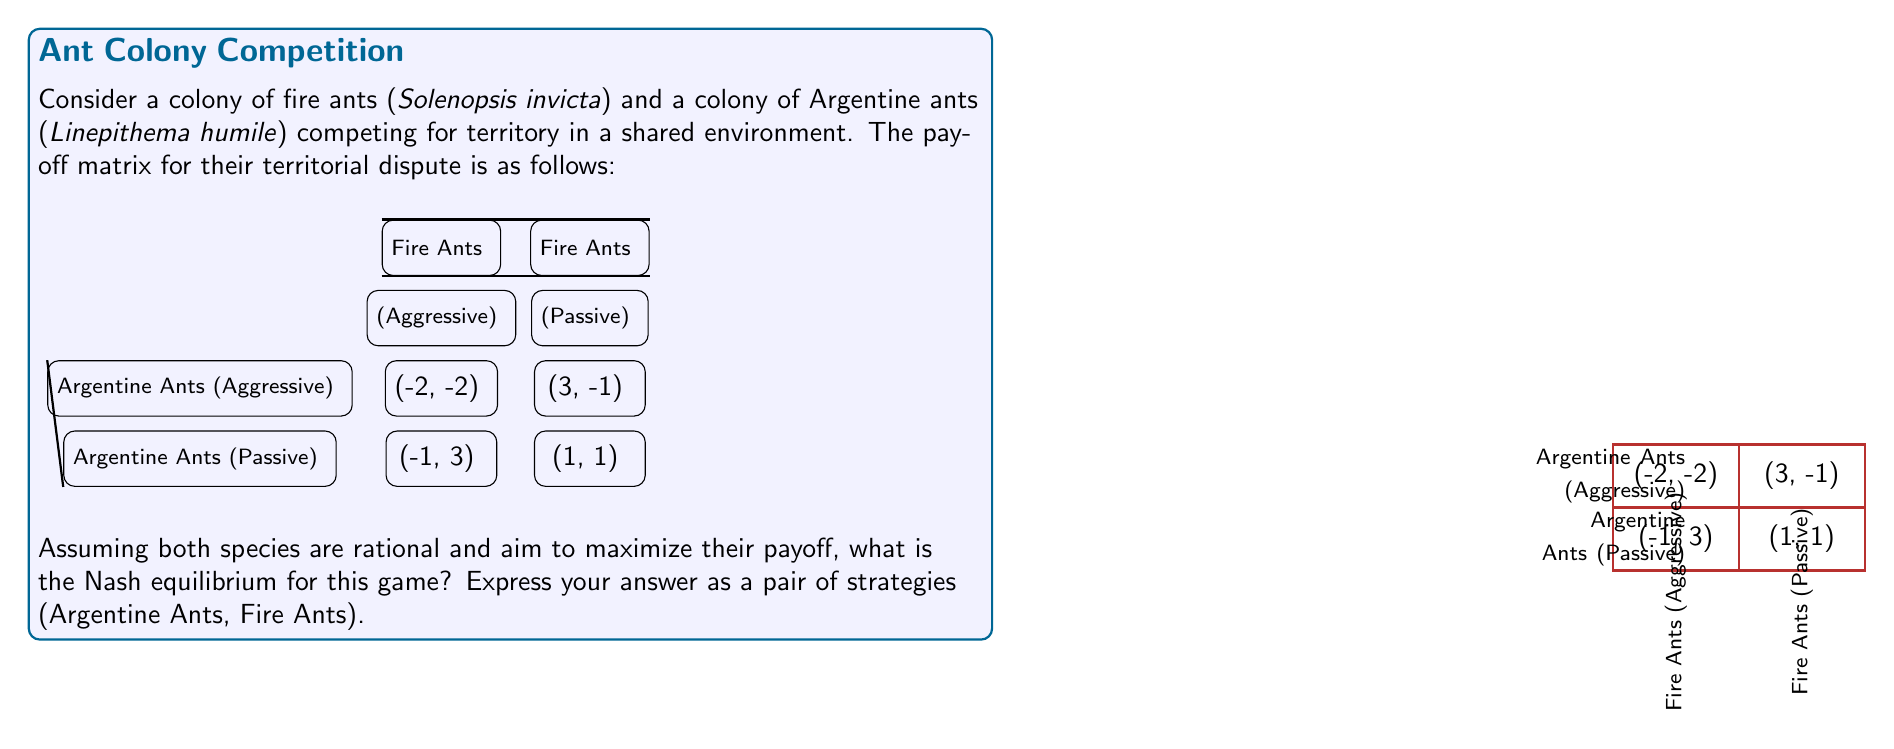Teach me how to tackle this problem. To find the Nash equilibrium, we need to analyze each species' best response to the other's strategy:

1. For Argentine Ants:
   - If Fire Ants play Aggressive: 
     Argentine Ants prefer Passive (-1 > -2)
   - If Fire Ants play Passive: 
     Argentine Ants prefer Aggressive (3 > 1)

2. For Fire Ants:
   - If Argentine Ants play Aggressive: 
     Fire Ants prefer Passive (-1 > -2)
   - If Argentine Ants play Passive: 
     Fire Ants prefer Aggressive (3 > 1)

3. We can see that there's no pure strategy Nash equilibrium, as no pair of strategies is a best response to each other.

4. For mixed strategy equilibrium, let:
   $p$ = probability of Argentine Ants playing Aggressive
   $q$ = probability of Fire Ants playing Aggressive

5. For Argentine Ants to be indifferent:
   $$-2q + 3(1-q) = -1q + 1(1-q)$$
   $$-2q + 3 - 3q = -q + 1$$
   $$-5q + 3 = -q + 1$$
   $$-4q = -2$$
   $$q = \frac{1}{2}$$

6. For Fire Ants to be indifferent:
   $$-2p + 3(1-p) = -1p + 1(1-p)$$
   $$-2p + 3 - 3p = -p + 1$$
   $$-5p + 3 = -p + 1$$
   $$-4p = -2$$
   $$p = \frac{1}{2}$$

7. Therefore, the mixed strategy Nash equilibrium is where both species play Aggressive with probability $\frac{1}{2}$ and Passive with probability $\frac{1}{2}$.
Answer: (50% Aggressive / 50% Passive, 50% Aggressive / 50% Passive) 